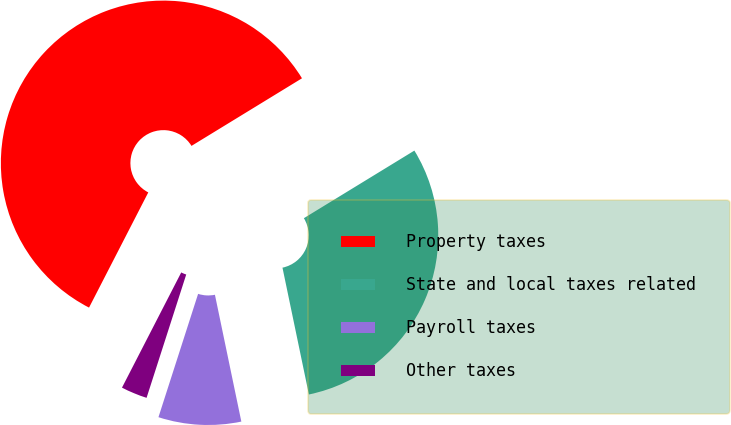<chart> <loc_0><loc_0><loc_500><loc_500><pie_chart><fcel>Property taxes<fcel>State and local taxes related<fcel>Payroll taxes<fcel>Other taxes<nl><fcel>58.7%<fcel>30.47%<fcel>8.22%<fcel>2.61%<nl></chart> 